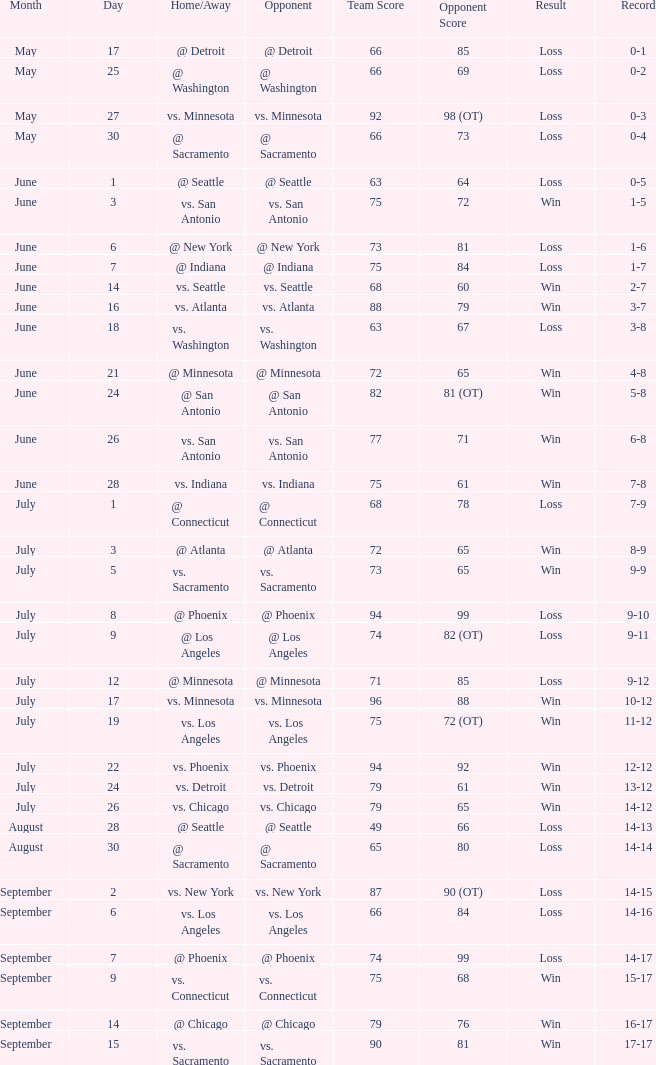What was the Result on May 30? Loss. 